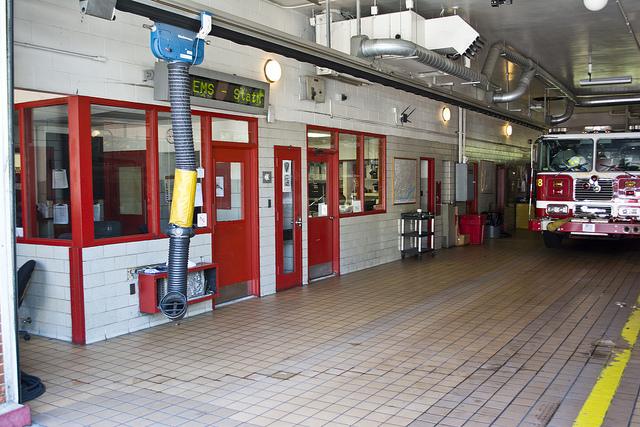Is this a hospital?
Answer briefly. No. Where are we?
Write a very short answer. Fire station. What color is the truck?
Short answer required. Red. 